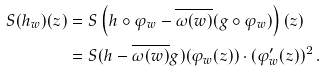<formula> <loc_0><loc_0><loc_500><loc_500>S ( h _ { w } ) ( z ) & = S \left ( h \circ \varphi _ { w } - \overline { \omega ( w ) } ( g \circ \varphi _ { w } ) \right ) ( z ) \\ & = S ( h - \overline { \omega ( w ) } g ) ( \varphi _ { w } ( z ) ) \cdot ( \varphi ^ { \prime } _ { w } ( z ) ) ^ { 2 } \, .</formula> 